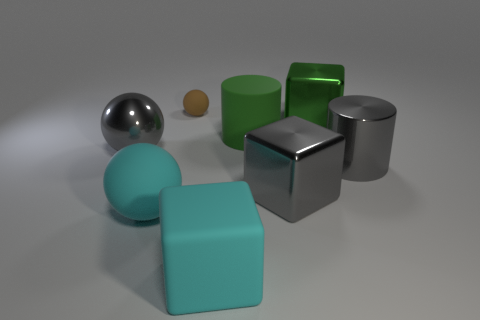What is the material of the block that is behind the big matte cube and left of the green cube?
Your answer should be very brief. Metal. Do the big gray cylinder and the green cylinder have the same material?
Offer a very short reply. No. What number of green cylinders have the same size as the gray metal cube?
Offer a very short reply. 1. Are there an equal number of cyan balls that are in front of the small brown rubber sphere and rubber objects?
Make the answer very short. No. How many rubber things are on the right side of the small brown sphere and behind the rubber block?
Make the answer very short. 1. There is a gray thing that is to the left of the small matte sphere; is its shape the same as the big green metallic thing?
Keep it short and to the point. No. There is a gray cylinder that is the same size as the cyan block; what is its material?
Offer a terse response. Metal. Are there the same number of objects in front of the gray metallic sphere and rubber objects behind the large cyan matte cube?
Give a very brief answer. No. What number of shiny cubes are on the right side of the cylinder that is behind the shiny object that is left of the tiny matte object?
Provide a short and direct response. 2. Is the color of the large rubber sphere the same as the big cylinder in front of the big green rubber thing?
Your answer should be very brief. No. 